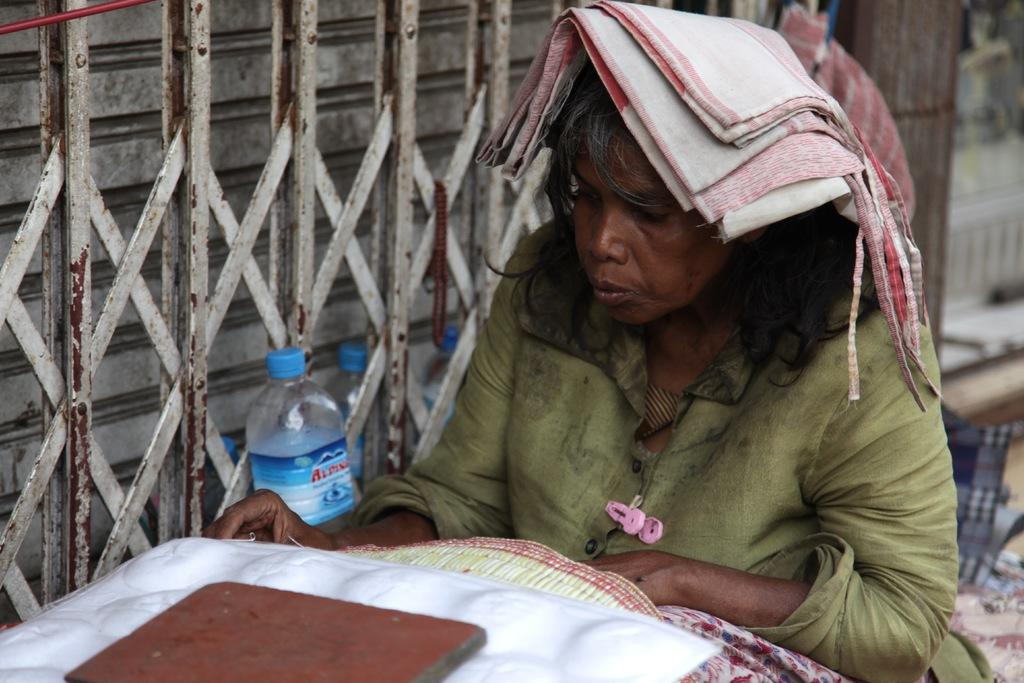What is the woman doing in the image? The woman is sitting in the image. What object can be seen beside the woman? There is a bottle in the image. What type of material is present in the image? There is a cloth in the image. What is the woman's income in the image? There is no information about the woman's income in the image. 